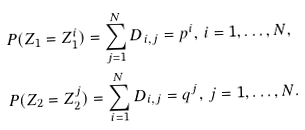<formula> <loc_0><loc_0><loc_500><loc_500>& P ( Z _ { 1 } = Z _ { 1 } ^ { i } ) = \sum _ { j = 1 } ^ { N } D _ { i , j } = p ^ { i } , \, i = 1 , \dots , N , \\ & P ( Z _ { 2 } = Z _ { 2 } ^ { j } ) = \sum _ { i = 1 } ^ { N } D _ { i , j } = q ^ { j } , \, j = 1 , \dots , N .</formula> 